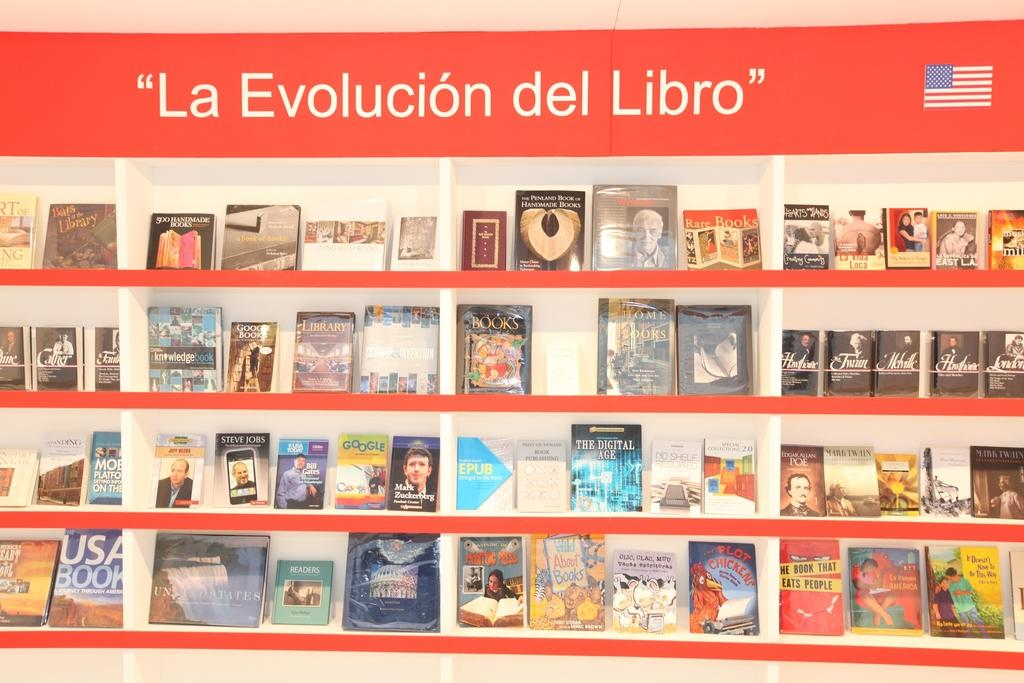<image>
Describe the image concisely. A book shelf in a store says La Evolucion del Libro. 